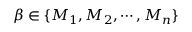Convert formula to latex. <formula><loc_0><loc_0><loc_500><loc_500>\beta \in \{ M _ { 1 } , M _ { 2 } , \cdots , M _ { n } \}</formula> 